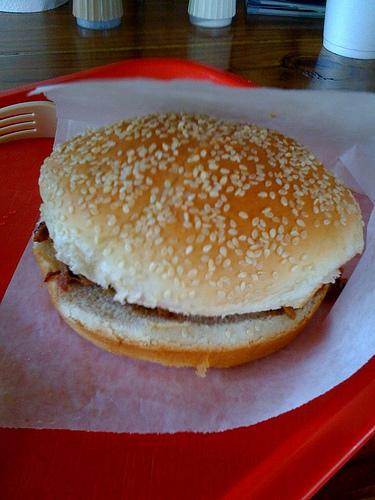What food is this?
Answer briefly. Hamburger. Is that healthy?
Answer briefly. No. Does this picture represent a full meal?
Quick response, please. No. 